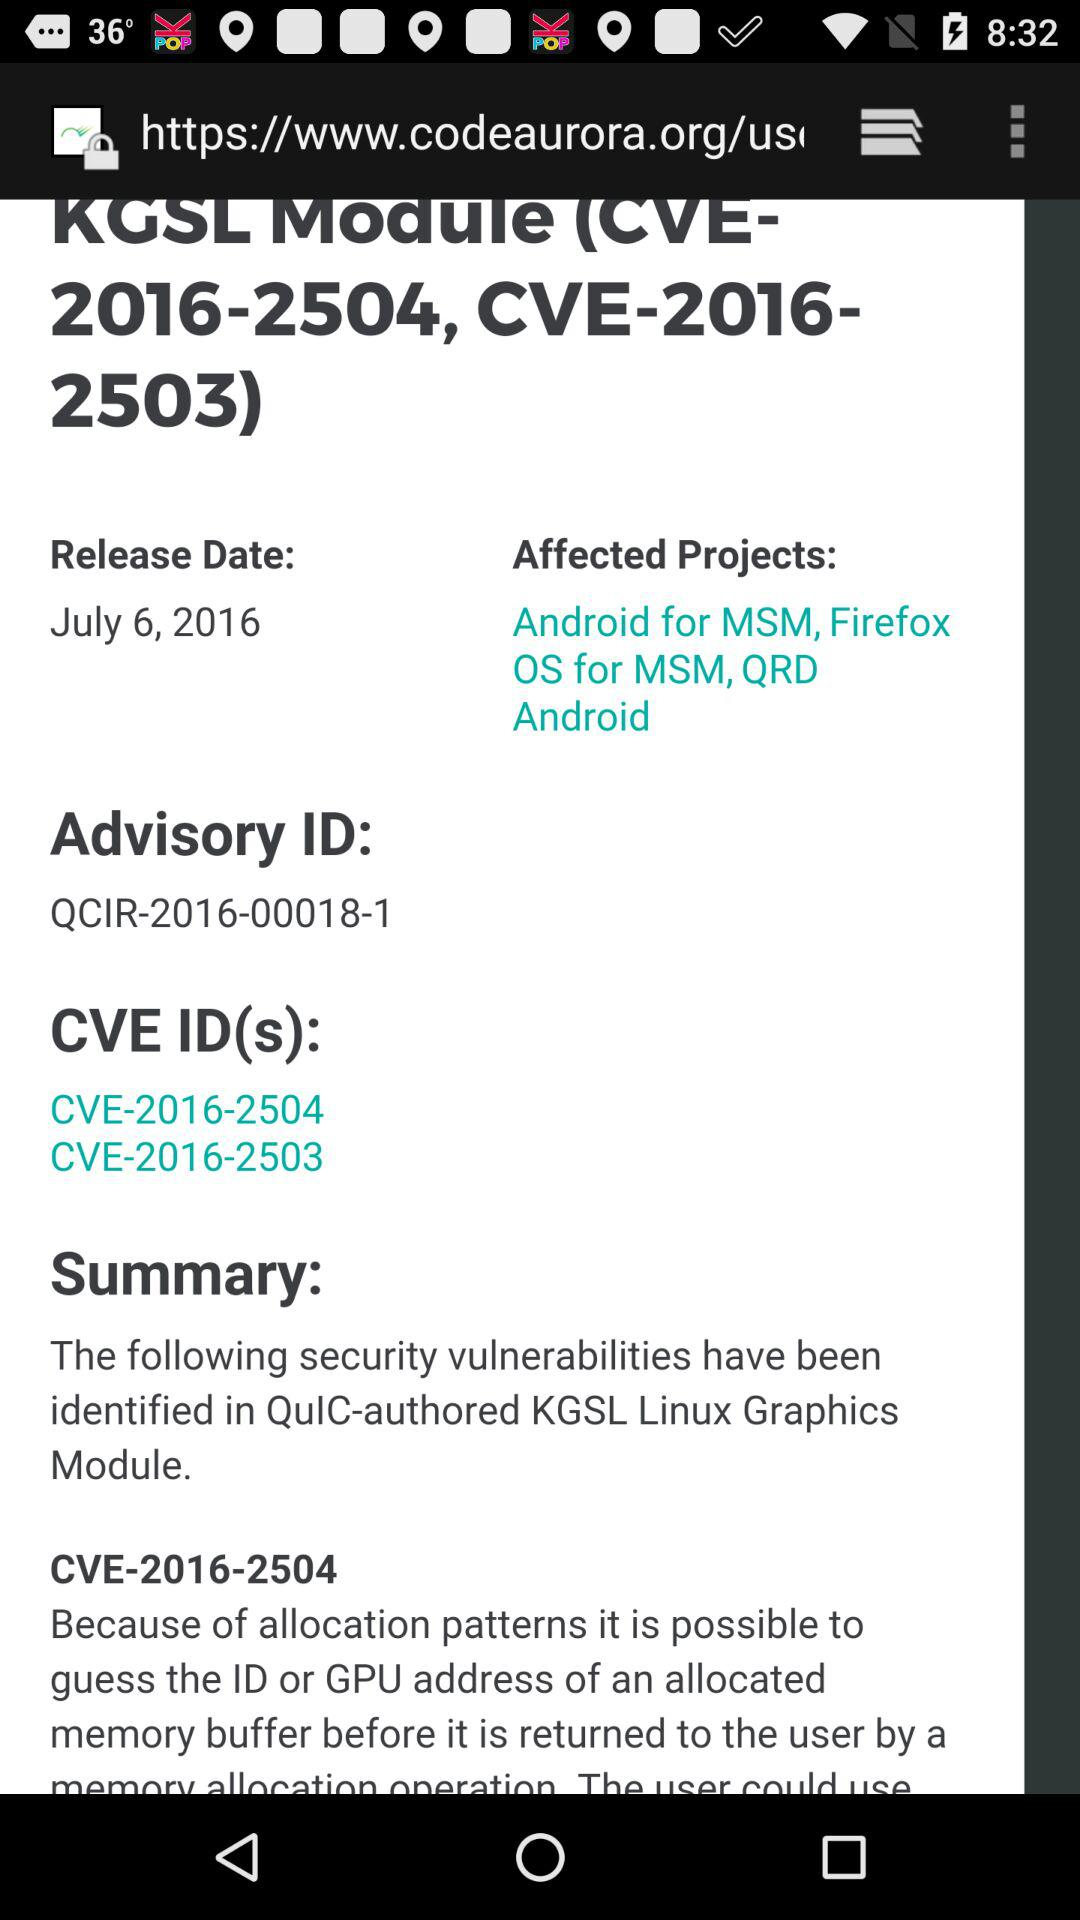What are the CVE IDs? The CVE IDs are CVE-2016-2504 and CVE-2016-2503. 